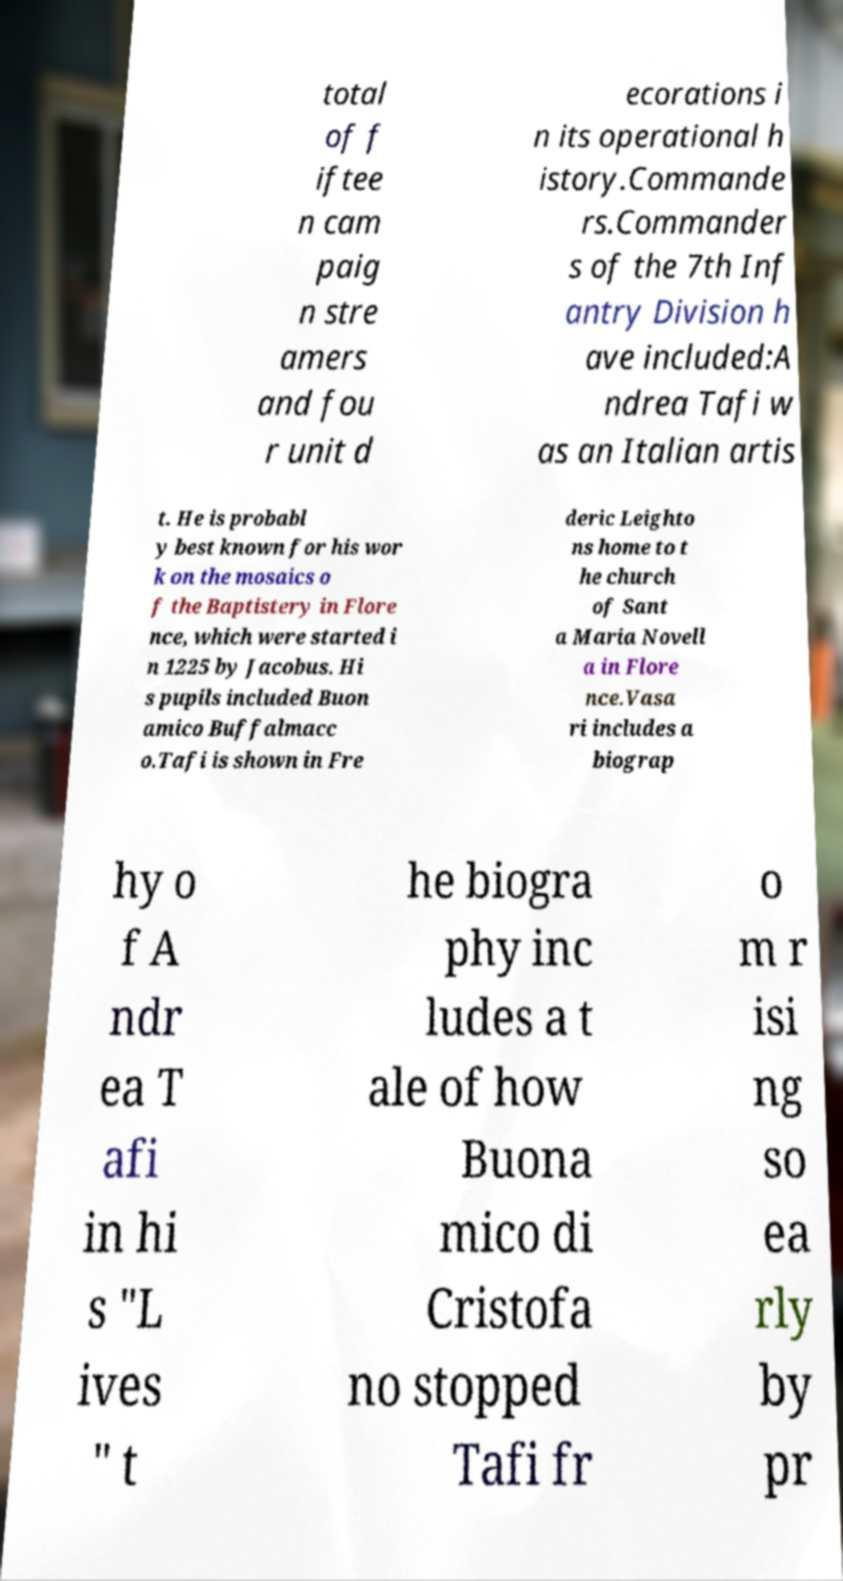Can you accurately transcribe the text from the provided image for me? total of f iftee n cam paig n stre amers and fou r unit d ecorations i n its operational h istory.Commande rs.Commander s of the 7th Inf antry Division h ave included:A ndrea Tafi w as an Italian artis t. He is probabl y best known for his wor k on the mosaics o f the Baptistery in Flore nce, which were started i n 1225 by Jacobus. Hi s pupils included Buon amico Buffalmacc o.Tafi is shown in Fre deric Leighto ns home to t he church of Sant a Maria Novell a in Flore nce.Vasa ri includes a biograp hy o f A ndr ea T afi in hi s "L ives " t he biogra phy inc ludes a t ale of how Buona mico di Cristofa no stopped Tafi fr o m r isi ng so ea rly by pr 